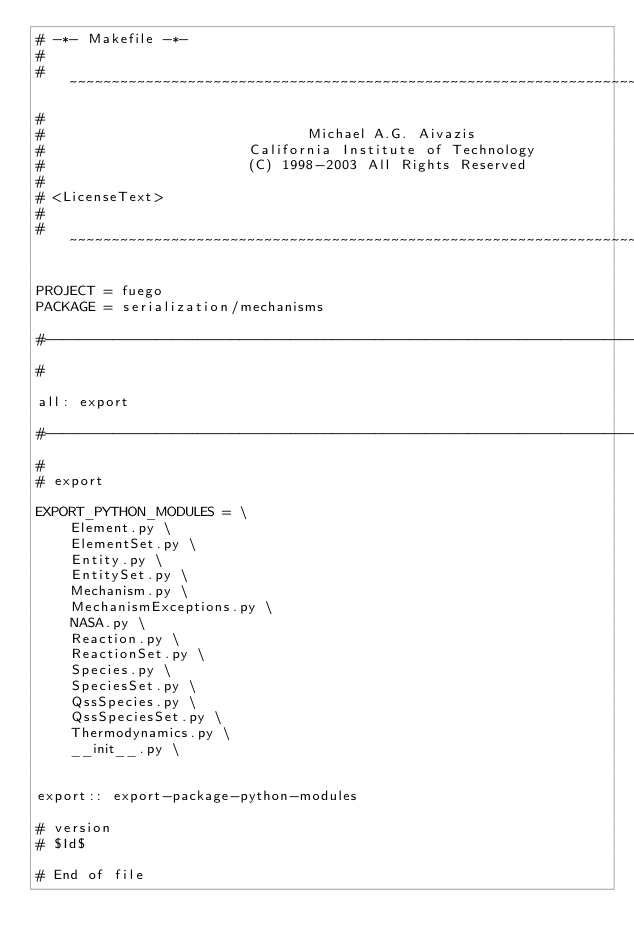Convert code to text. <code><loc_0><loc_0><loc_500><loc_500><_ObjectiveC_># -*- Makefile -*-
#
# ~~~~~~~~~~~~~~~~~~~~~~~~~~~~~~~~~~~~~~~~~~~~~~~~~~~~~~~~~~~~~~~~~~~~~~~~~~~~~~~~
#
#                               Michael A.G. Aivazis
#                        California Institute of Technology
#                        (C) 1998-2003 All Rights Reserved
#
# <LicenseText>
#
# ~~~~~~~~~~~~~~~~~~~~~~~~~~~~~~~~~~~~~~~~~~~~~~~~~~~~~~~~~~~~~~~~~~~~~~~~~~~~~~~~

PROJECT = fuego
PACKAGE = serialization/mechanisms

#--------------------------------------------------------------------------
#

all: export

#--------------------------------------------------------------------------
#
# export

EXPORT_PYTHON_MODULES = \
    Element.py \
    ElementSet.py \
    Entity.py \
    EntitySet.py \
    Mechanism.py \
    MechanismExceptions.py \
    NASA.py \
    Reaction.py \
    ReactionSet.py \
    Species.py \
    SpeciesSet.py \
    QssSpecies.py \
    QssSpeciesSet.py \
    Thermodynamics.py \
    __init__.py \


export:: export-package-python-modules

# version
# $Id$

# End of file
</code> 